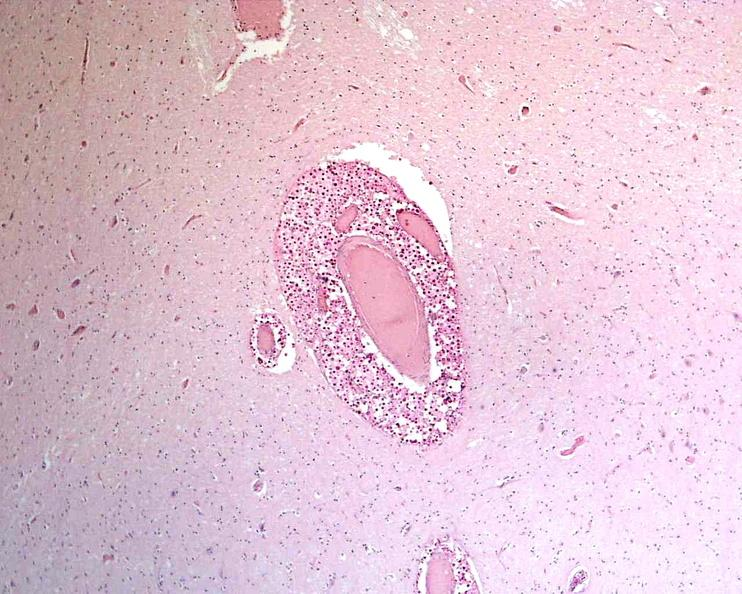does lymphangiomatosis generalized show brain, cryptococcal meningitis?
Answer the question using a single word or phrase. No 